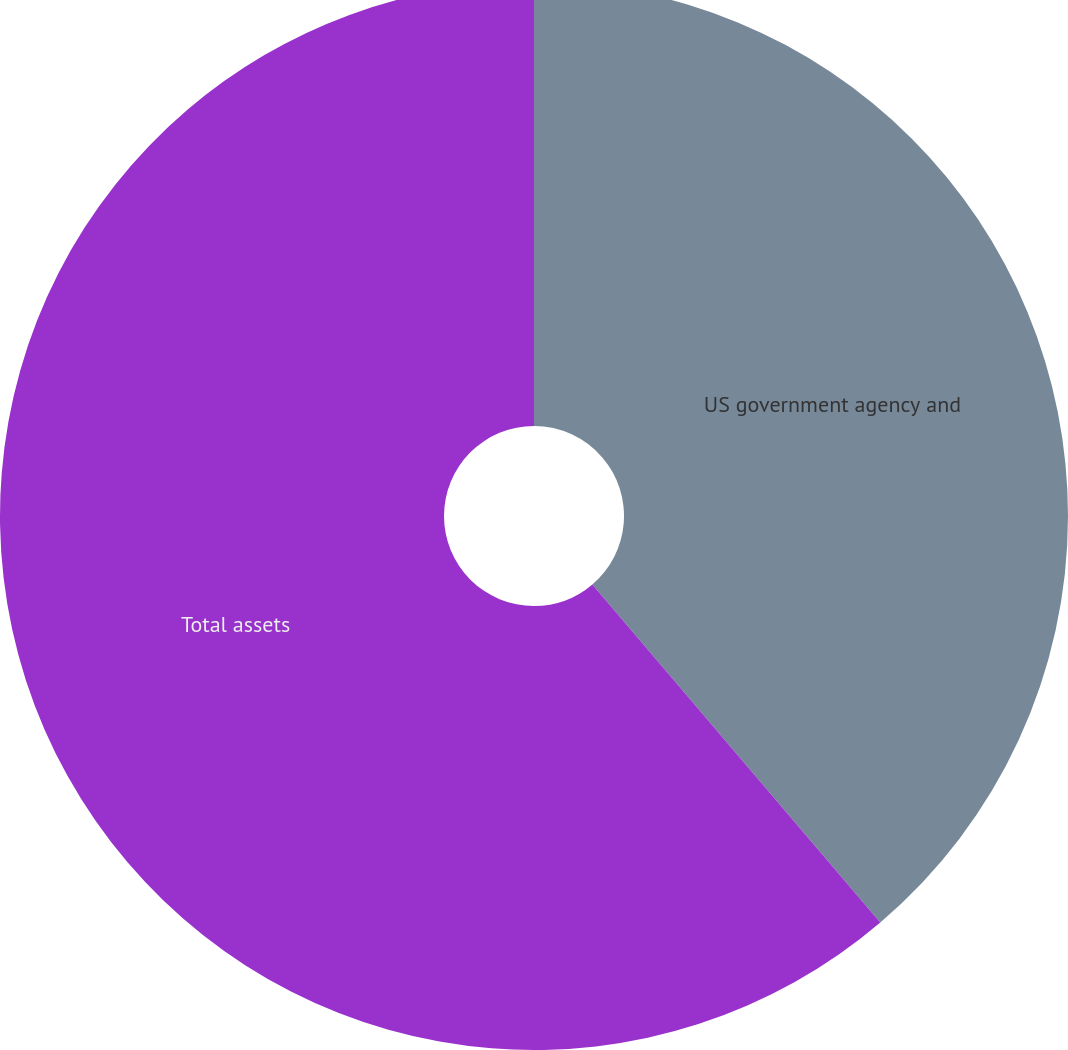Convert chart. <chart><loc_0><loc_0><loc_500><loc_500><pie_chart><fcel>US government agency and<fcel>Total assets<nl><fcel>38.77%<fcel>61.23%<nl></chart> 